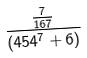Convert formula to latex. <formula><loc_0><loc_0><loc_500><loc_500>\frac { \frac { 7 } { 1 6 7 } } { ( 4 5 4 ^ { 7 } + 6 ) }</formula> 